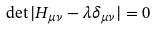Convert formula to latex. <formula><loc_0><loc_0><loc_500><loc_500>\det | H _ { \mu \nu } - \lambda \delta _ { \mu \nu } | = 0</formula> 